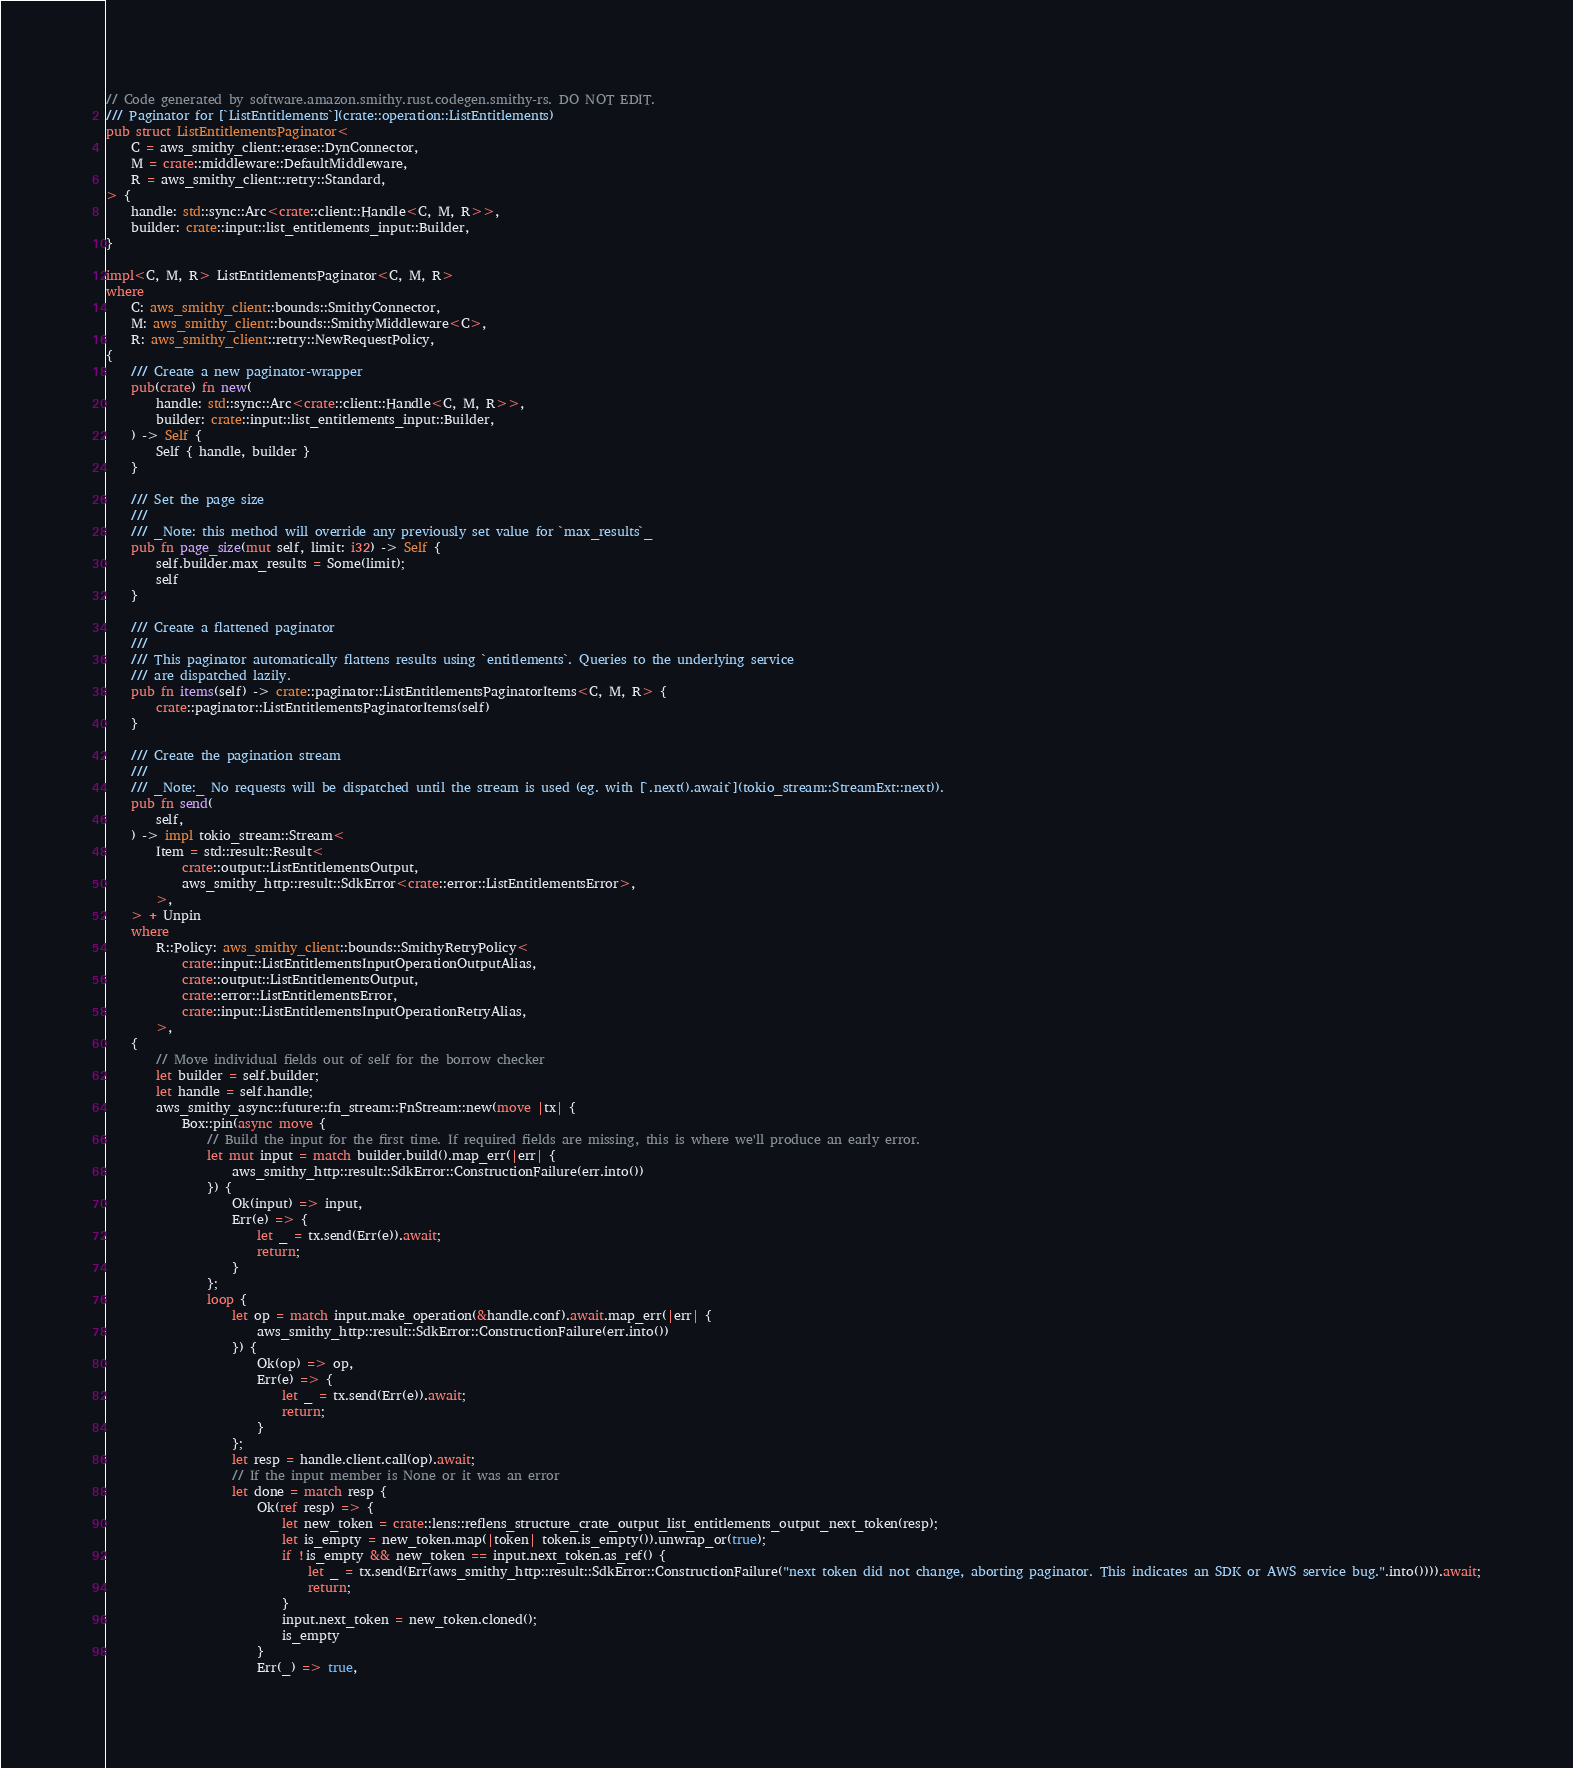Convert code to text. <code><loc_0><loc_0><loc_500><loc_500><_Rust_>// Code generated by software.amazon.smithy.rust.codegen.smithy-rs. DO NOT EDIT.
/// Paginator for [`ListEntitlements`](crate::operation::ListEntitlements)
pub struct ListEntitlementsPaginator<
    C = aws_smithy_client::erase::DynConnector,
    M = crate::middleware::DefaultMiddleware,
    R = aws_smithy_client::retry::Standard,
> {
    handle: std::sync::Arc<crate::client::Handle<C, M, R>>,
    builder: crate::input::list_entitlements_input::Builder,
}

impl<C, M, R> ListEntitlementsPaginator<C, M, R>
where
    C: aws_smithy_client::bounds::SmithyConnector,
    M: aws_smithy_client::bounds::SmithyMiddleware<C>,
    R: aws_smithy_client::retry::NewRequestPolicy,
{
    /// Create a new paginator-wrapper
    pub(crate) fn new(
        handle: std::sync::Arc<crate::client::Handle<C, M, R>>,
        builder: crate::input::list_entitlements_input::Builder,
    ) -> Self {
        Self { handle, builder }
    }

    /// Set the page size
    ///
    /// _Note: this method will override any previously set value for `max_results`_
    pub fn page_size(mut self, limit: i32) -> Self {
        self.builder.max_results = Some(limit);
        self
    }

    /// Create a flattened paginator
    ///
    /// This paginator automatically flattens results using `entitlements`. Queries to the underlying service
    /// are dispatched lazily.
    pub fn items(self) -> crate::paginator::ListEntitlementsPaginatorItems<C, M, R> {
        crate::paginator::ListEntitlementsPaginatorItems(self)
    }

    /// Create the pagination stream
    ///
    /// _Note:_ No requests will be dispatched until the stream is used (eg. with [`.next().await`](tokio_stream::StreamExt::next)).
    pub fn send(
        self,
    ) -> impl tokio_stream::Stream<
        Item = std::result::Result<
            crate::output::ListEntitlementsOutput,
            aws_smithy_http::result::SdkError<crate::error::ListEntitlementsError>,
        >,
    > + Unpin
    where
        R::Policy: aws_smithy_client::bounds::SmithyRetryPolicy<
            crate::input::ListEntitlementsInputOperationOutputAlias,
            crate::output::ListEntitlementsOutput,
            crate::error::ListEntitlementsError,
            crate::input::ListEntitlementsInputOperationRetryAlias,
        >,
    {
        // Move individual fields out of self for the borrow checker
        let builder = self.builder;
        let handle = self.handle;
        aws_smithy_async::future::fn_stream::FnStream::new(move |tx| {
            Box::pin(async move {
                // Build the input for the first time. If required fields are missing, this is where we'll produce an early error.
                let mut input = match builder.build().map_err(|err| {
                    aws_smithy_http::result::SdkError::ConstructionFailure(err.into())
                }) {
                    Ok(input) => input,
                    Err(e) => {
                        let _ = tx.send(Err(e)).await;
                        return;
                    }
                };
                loop {
                    let op = match input.make_operation(&handle.conf).await.map_err(|err| {
                        aws_smithy_http::result::SdkError::ConstructionFailure(err.into())
                    }) {
                        Ok(op) => op,
                        Err(e) => {
                            let _ = tx.send(Err(e)).await;
                            return;
                        }
                    };
                    let resp = handle.client.call(op).await;
                    // If the input member is None or it was an error
                    let done = match resp {
                        Ok(ref resp) => {
                            let new_token = crate::lens::reflens_structure_crate_output_list_entitlements_output_next_token(resp);
                            let is_empty = new_token.map(|token| token.is_empty()).unwrap_or(true);
                            if !is_empty && new_token == input.next_token.as_ref() {
                                let _ = tx.send(Err(aws_smithy_http::result::SdkError::ConstructionFailure("next token did not change, aborting paginator. This indicates an SDK or AWS service bug.".into()))).await;
                                return;
                            }
                            input.next_token = new_token.cloned();
                            is_empty
                        }
                        Err(_) => true,</code> 